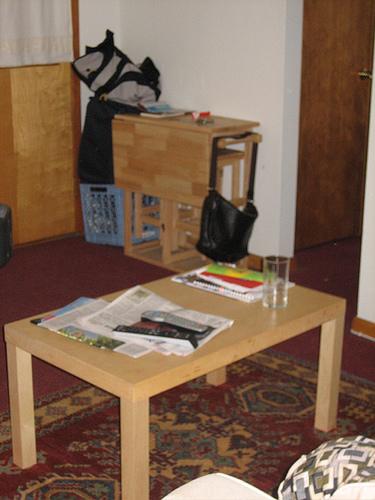Is the glass empty?
Give a very brief answer. Yes. What is the color of the wall?
Concise answer only. White. What color is the purse hanging on the table?
Short answer required. Black. 